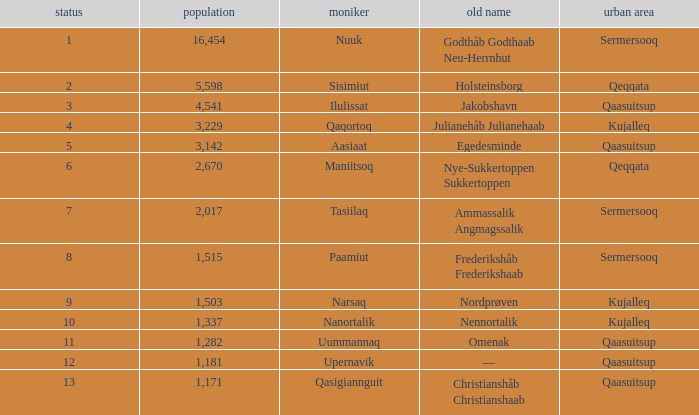Who has a former name of nordprøven? Narsaq. 